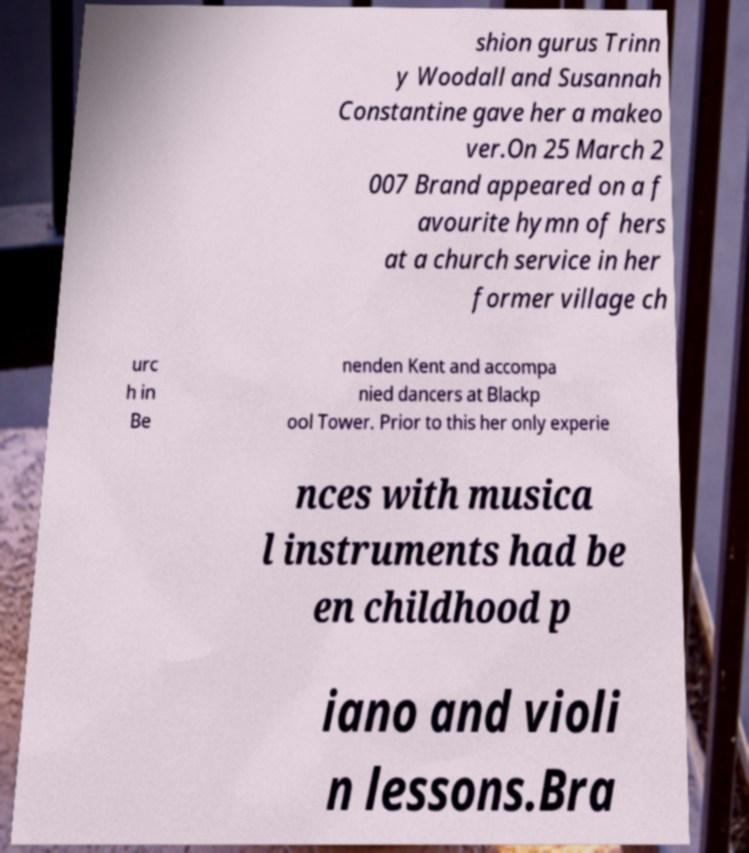I need the written content from this picture converted into text. Can you do that? shion gurus Trinn y Woodall and Susannah Constantine gave her a makeo ver.On 25 March 2 007 Brand appeared on a f avourite hymn of hers at a church service in her former village ch urc h in Be nenden Kent and accompa nied dancers at Blackp ool Tower. Prior to this her only experie nces with musica l instruments had be en childhood p iano and violi n lessons.Bra 